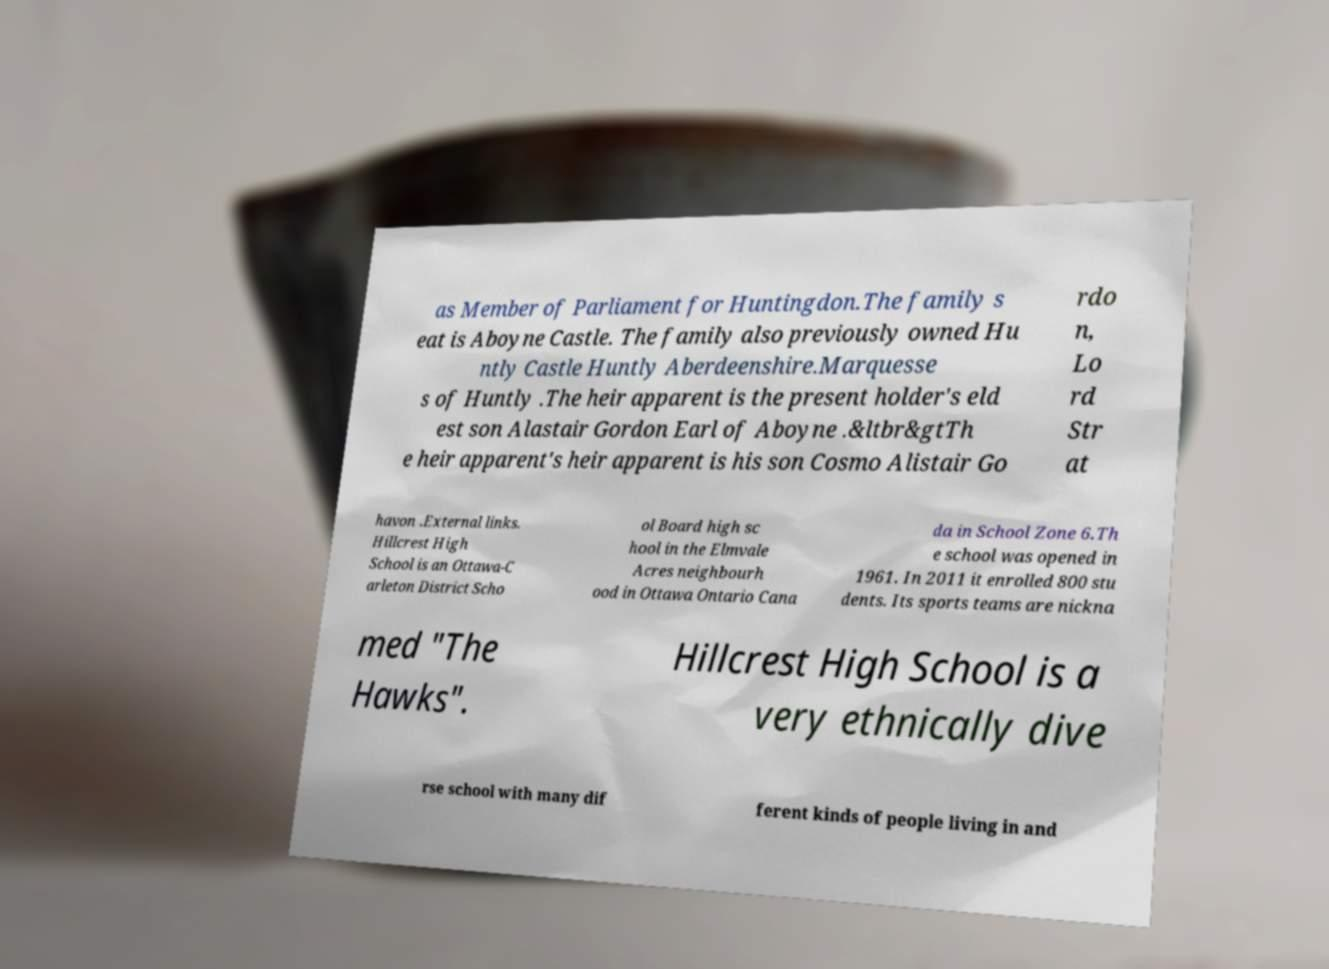I need the written content from this picture converted into text. Can you do that? as Member of Parliament for Huntingdon.The family s eat is Aboyne Castle. The family also previously owned Hu ntly Castle Huntly Aberdeenshire.Marquesse s of Huntly .The heir apparent is the present holder's eld est son Alastair Gordon Earl of Aboyne .&ltbr&gtTh e heir apparent's heir apparent is his son Cosmo Alistair Go rdo n, Lo rd Str at havon .External links. Hillcrest High School is an Ottawa-C arleton District Scho ol Board high sc hool in the Elmvale Acres neighbourh ood in Ottawa Ontario Cana da in School Zone 6.Th e school was opened in 1961. In 2011 it enrolled 800 stu dents. Its sports teams are nickna med "The Hawks". Hillcrest High School is a very ethnically dive rse school with many dif ferent kinds of people living in and 